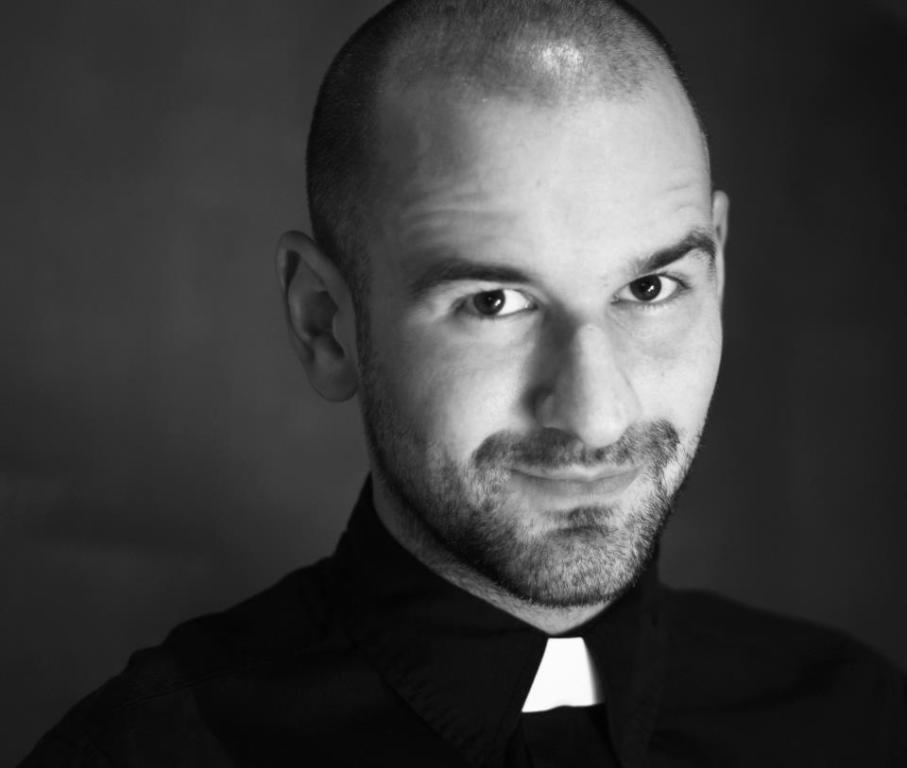How would you summarize this image in a sentence or two? This is a black and white image. In this image we can see a person. 